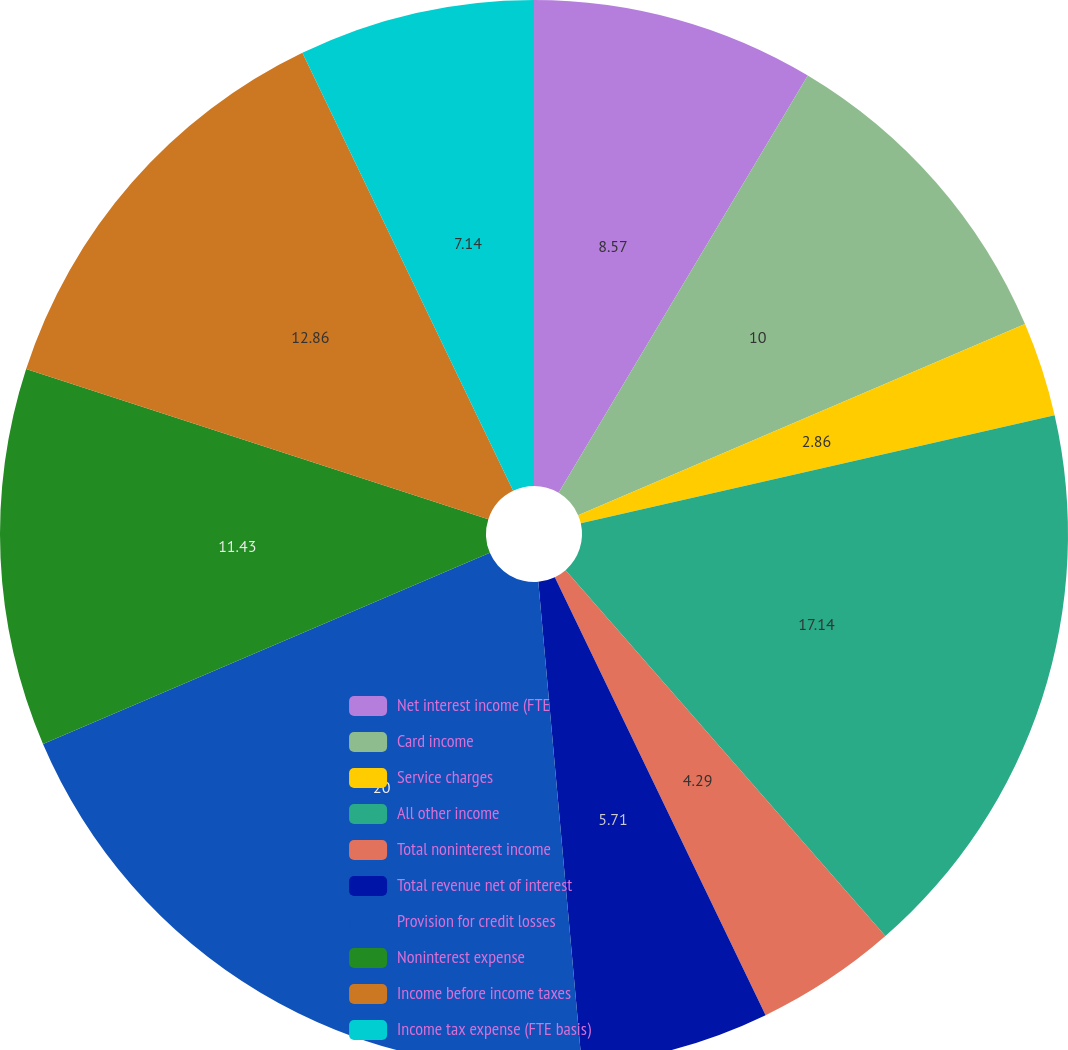Convert chart to OTSL. <chart><loc_0><loc_0><loc_500><loc_500><pie_chart><fcel>Net interest income (FTE<fcel>Card income<fcel>Service charges<fcel>All other income<fcel>Total noninterest income<fcel>Total revenue net of interest<fcel>Provision for credit losses<fcel>Noninterest expense<fcel>Income before income taxes<fcel>Income tax expense (FTE basis)<nl><fcel>8.57%<fcel>10.0%<fcel>2.86%<fcel>17.14%<fcel>4.29%<fcel>5.71%<fcel>20.0%<fcel>11.43%<fcel>12.86%<fcel>7.14%<nl></chart> 